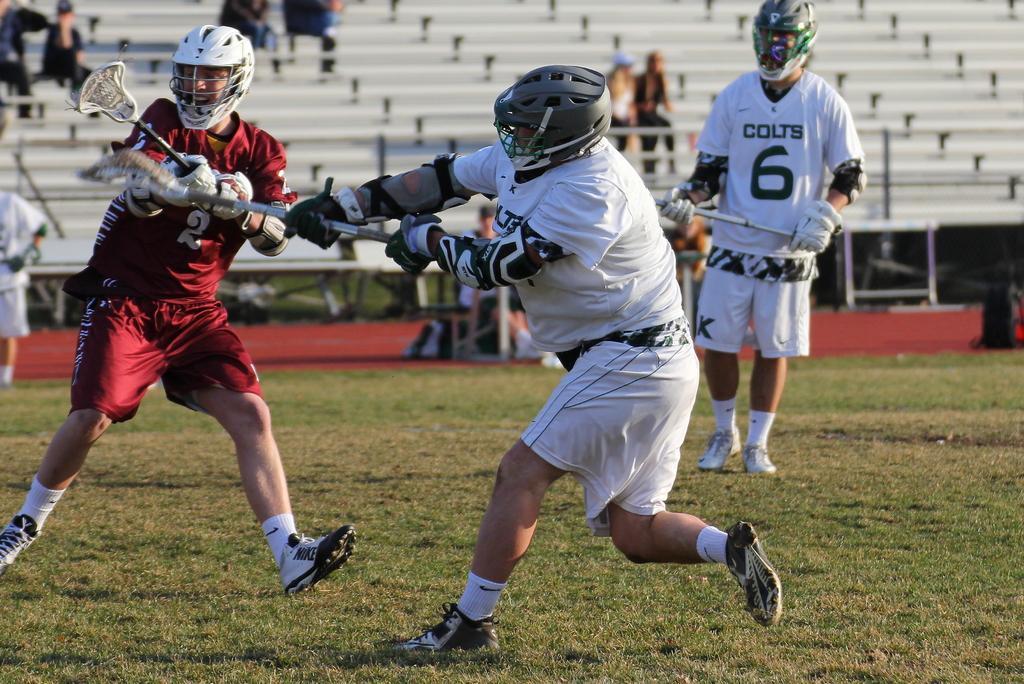Could you give a brief overview of what you see in this image? This picture is clicked outside. In the center we can see the group of people holding the sticks and seems to be standing on the ground and we can see the green grass. In the background we can see the group of people seems to be sitting on the benches, and we can see a person in the left corner. 